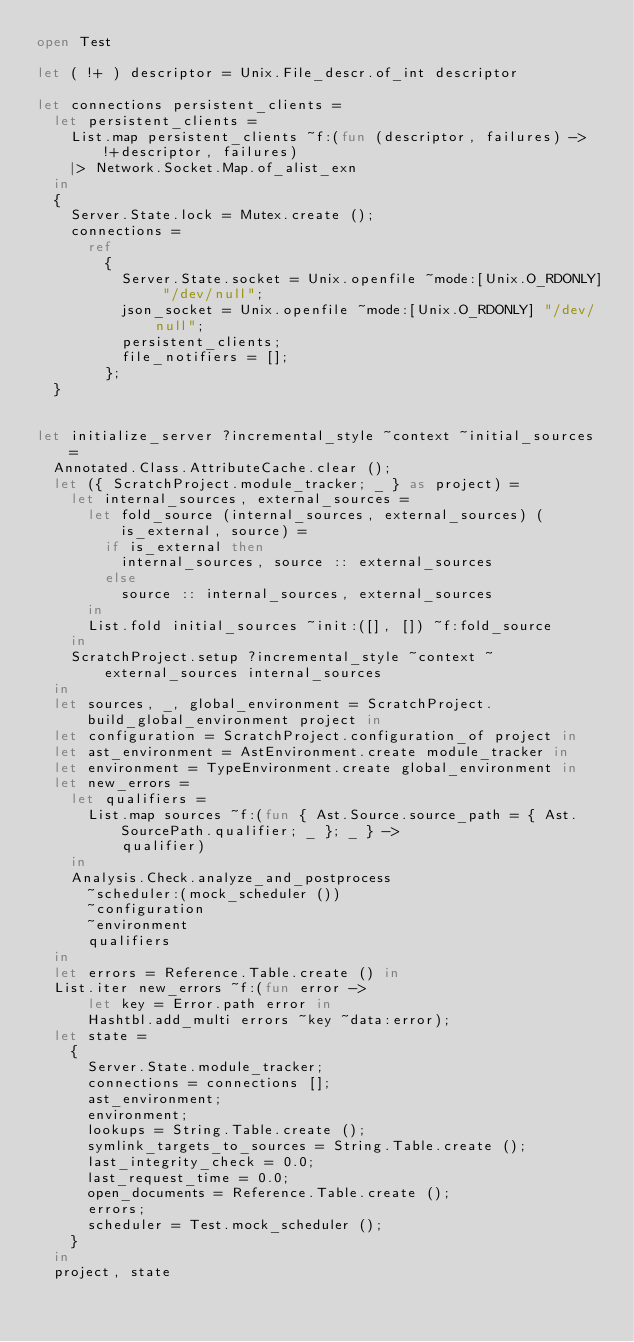Convert code to text. <code><loc_0><loc_0><loc_500><loc_500><_OCaml_>open Test

let ( !+ ) descriptor = Unix.File_descr.of_int descriptor

let connections persistent_clients =
  let persistent_clients =
    List.map persistent_clients ~f:(fun (descriptor, failures) -> !+descriptor, failures)
    |> Network.Socket.Map.of_alist_exn
  in
  {
    Server.State.lock = Mutex.create ();
    connections =
      ref
        {
          Server.State.socket = Unix.openfile ~mode:[Unix.O_RDONLY] "/dev/null";
          json_socket = Unix.openfile ~mode:[Unix.O_RDONLY] "/dev/null";
          persistent_clients;
          file_notifiers = [];
        };
  }


let initialize_server ?incremental_style ~context ~initial_sources =
  Annotated.Class.AttributeCache.clear ();
  let ({ ScratchProject.module_tracker; _ } as project) =
    let internal_sources, external_sources =
      let fold_source (internal_sources, external_sources) (is_external, source) =
        if is_external then
          internal_sources, source :: external_sources
        else
          source :: internal_sources, external_sources
      in
      List.fold initial_sources ~init:([], []) ~f:fold_source
    in
    ScratchProject.setup ?incremental_style ~context ~external_sources internal_sources
  in
  let sources, _, global_environment = ScratchProject.build_global_environment project in
  let configuration = ScratchProject.configuration_of project in
  let ast_environment = AstEnvironment.create module_tracker in
  let environment = TypeEnvironment.create global_environment in
  let new_errors =
    let qualifiers =
      List.map sources ~f:(fun { Ast.Source.source_path = { Ast.SourcePath.qualifier; _ }; _ } ->
          qualifier)
    in
    Analysis.Check.analyze_and_postprocess
      ~scheduler:(mock_scheduler ())
      ~configuration
      ~environment
      qualifiers
  in
  let errors = Reference.Table.create () in
  List.iter new_errors ~f:(fun error ->
      let key = Error.path error in
      Hashtbl.add_multi errors ~key ~data:error);
  let state =
    {
      Server.State.module_tracker;
      connections = connections [];
      ast_environment;
      environment;
      lookups = String.Table.create ();
      symlink_targets_to_sources = String.Table.create ();
      last_integrity_check = 0.0;
      last_request_time = 0.0;
      open_documents = Reference.Table.create ();
      errors;
      scheduler = Test.mock_scheduler ();
    }
  in
  project, state
</code> 